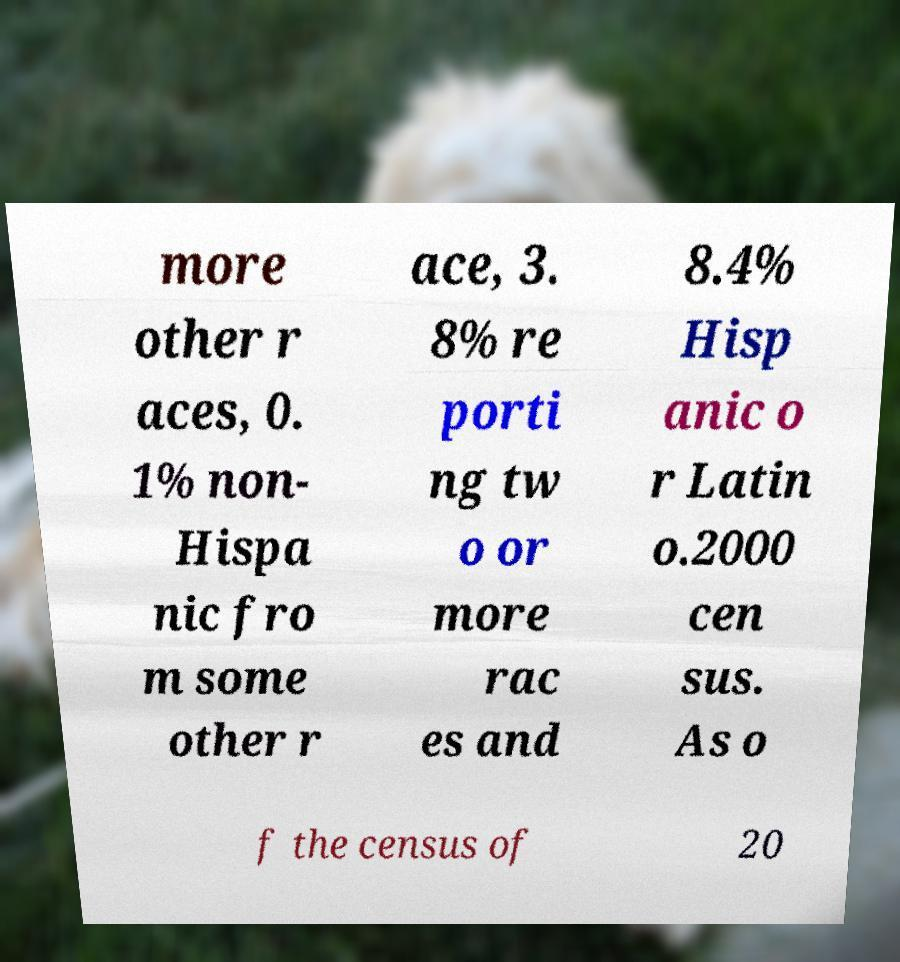For documentation purposes, I need the text within this image transcribed. Could you provide that? more other r aces, 0. 1% non- Hispa nic fro m some other r ace, 3. 8% re porti ng tw o or more rac es and 8.4% Hisp anic o r Latin o.2000 cen sus. As o f the census of 20 